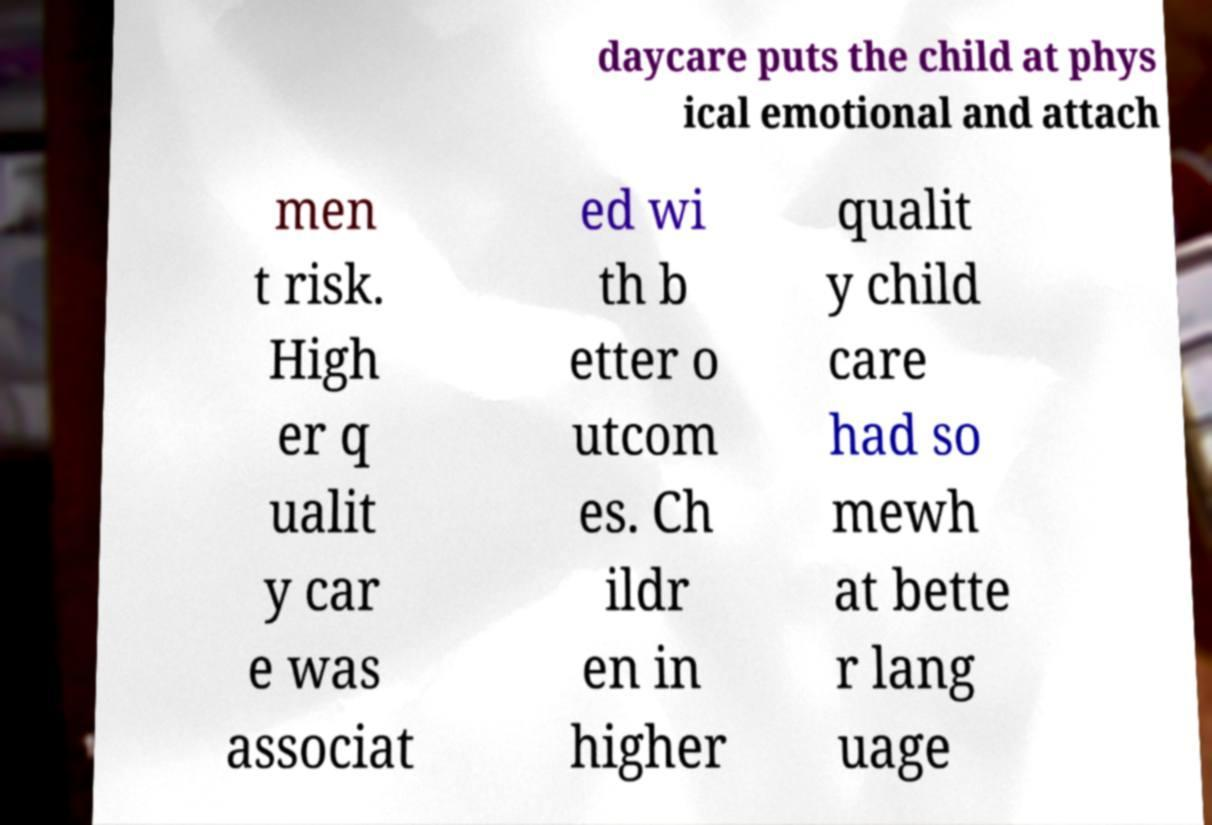Can you accurately transcribe the text from the provided image for me? daycare puts the child at phys ical emotional and attach men t risk. High er q ualit y car e was associat ed wi th b etter o utcom es. Ch ildr en in higher qualit y child care had so mewh at bette r lang uage 